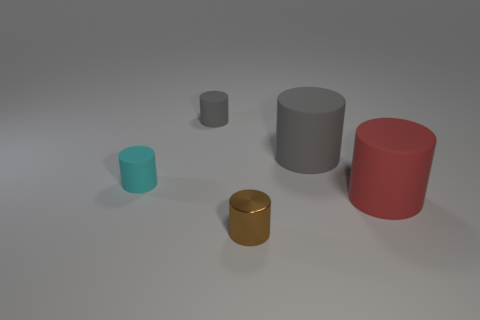Are there any other cylinders in the image that share the same color as the gold one? No, the gold cylinder is unique in its color among the cylinders shown. The others are teal, gray, and red, respectively. 